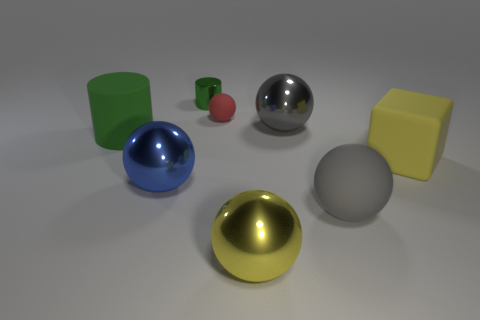Which objects appear to have more matte surfaces? The objects with matte surfaces in the image are the yellow cube and the green cylinder. They reflect less light and have a duller appearance compared to the shiny spheres. 